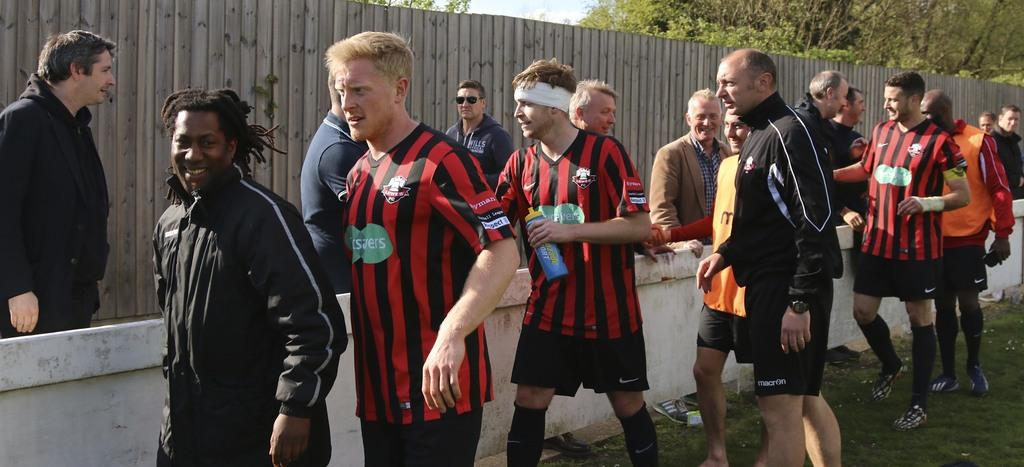How many people are visible in the image? There are many people standing in the image. What are the people wearing on their feet? The people are wearing shoes. Can you describe any accessories worn by the people in the image? There is a wrist watch, goggles, and a headband visible in the image. What type of natural environment is present in the image? There is grass, a wooden fence, trees, and the sky visible in the image. What is the total mass of the receipts in the image? There are no receipts present in the image, so it is not possible to determine their mass. 